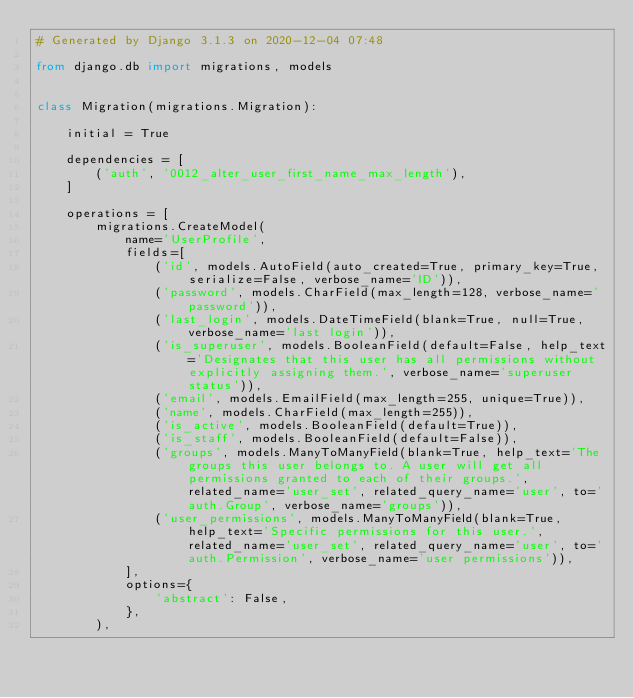<code> <loc_0><loc_0><loc_500><loc_500><_Python_># Generated by Django 3.1.3 on 2020-12-04 07:48

from django.db import migrations, models


class Migration(migrations.Migration):

    initial = True

    dependencies = [
        ('auth', '0012_alter_user_first_name_max_length'),
    ]

    operations = [
        migrations.CreateModel(
            name='UserProfile',
            fields=[
                ('id', models.AutoField(auto_created=True, primary_key=True, serialize=False, verbose_name='ID')),
                ('password', models.CharField(max_length=128, verbose_name='password')),
                ('last_login', models.DateTimeField(blank=True, null=True, verbose_name='last login')),
                ('is_superuser', models.BooleanField(default=False, help_text='Designates that this user has all permissions without explicitly assigning them.', verbose_name='superuser status')),
                ('email', models.EmailField(max_length=255, unique=True)),
                ('name', models.CharField(max_length=255)),
                ('is_active', models.BooleanField(default=True)),
                ('is_staff', models.BooleanField(default=False)),
                ('groups', models.ManyToManyField(blank=True, help_text='The groups this user belongs to. A user will get all permissions granted to each of their groups.', related_name='user_set', related_query_name='user', to='auth.Group', verbose_name='groups')),
                ('user_permissions', models.ManyToManyField(blank=True, help_text='Specific permissions for this user.', related_name='user_set', related_query_name='user', to='auth.Permission', verbose_name='user permissions')),
            ],
            options={
                'abstract': False,
            },
        ),</code> 